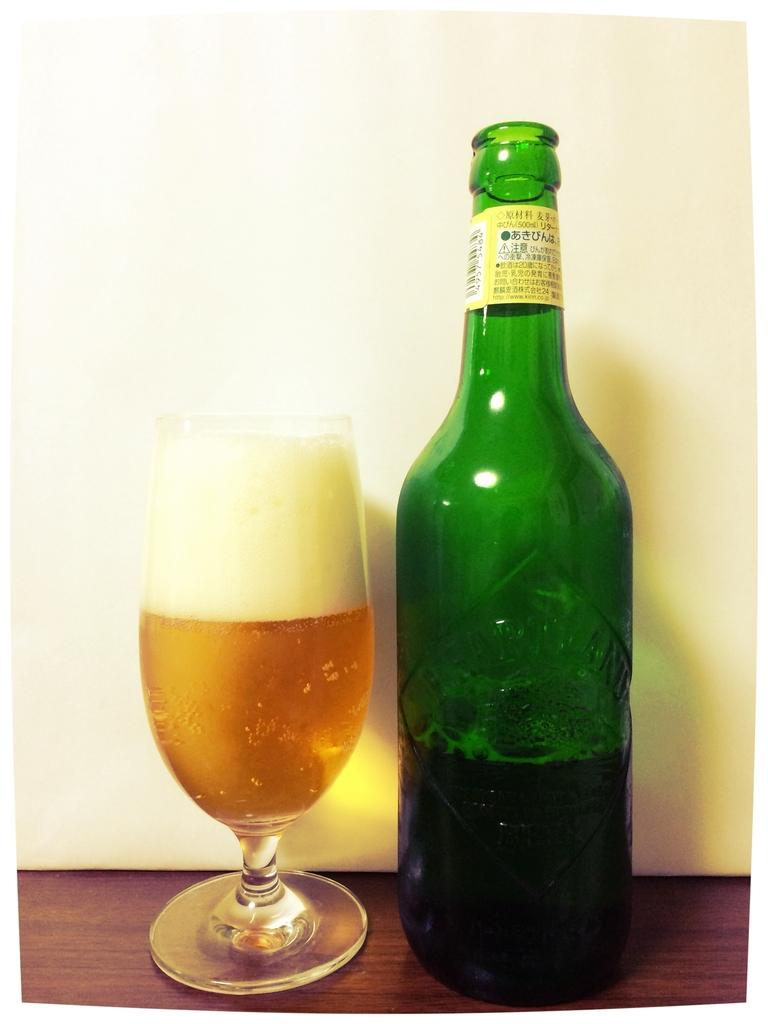What type of bottle is in the image? There is a green color bottle in the image. What other object is in the image related to serving beverages? There is a wine glass in the image. Where are the bottle and glass placed? The bottle and glass are on a wooden table. What color is the background of the image? The background of the image is a white-colored wall. Can you see a pig or a dog in the image? No, there are no animals present in the image. Is there a cannon visible in the image? No, there is no cannon present in the image. 